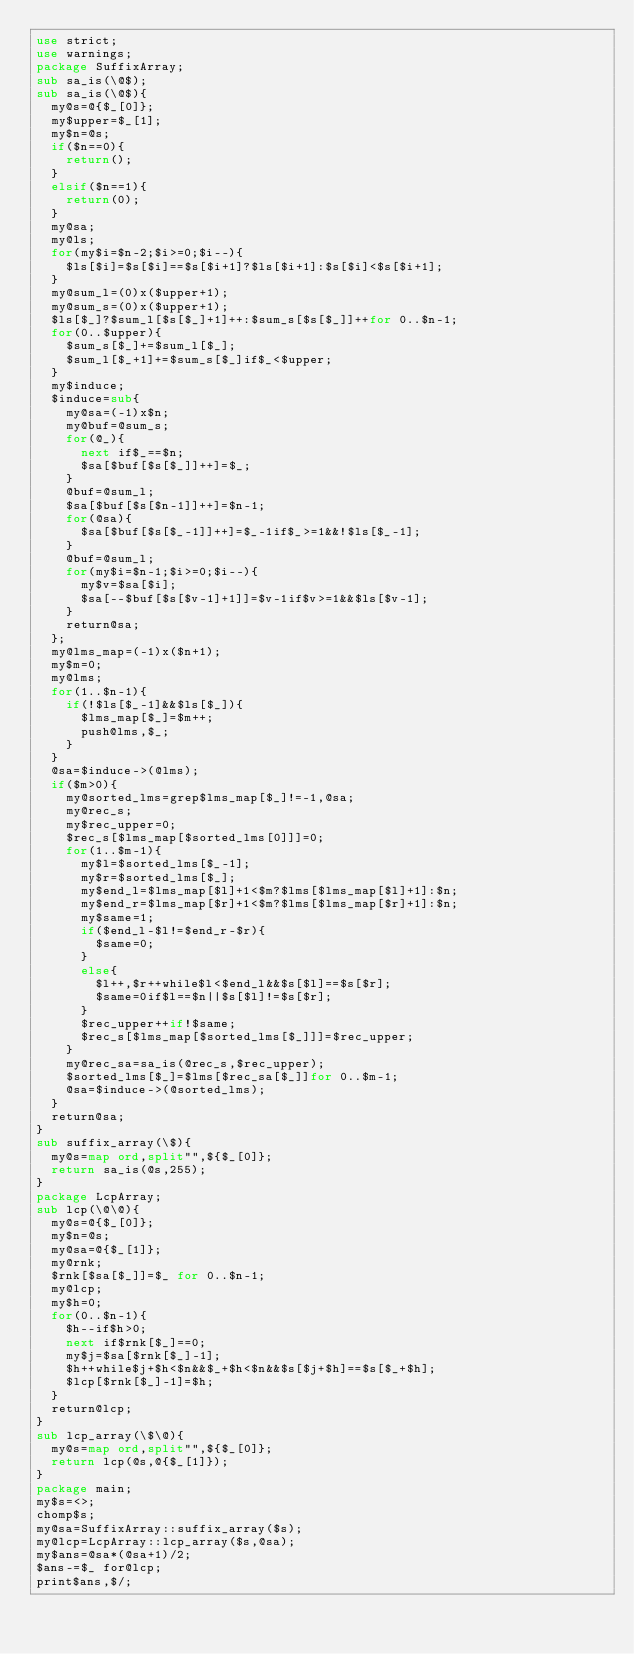<code> <loc_0><loc_0><loc_500><loc_500><_Perl_>use strict;
use warnings;
package SuffixArray;
sub sa_is(\@$);
sub sa_is(\@$){
	my@s=@{$_[0]};
	my$upper=$_[1];
	my$n=@s;
	if($n==0){
		return();
	}
	elsif($n==1){
		return(0);
	}
	my@sa;
	my@ls;
	for(my$i=$n-2;$i>=0;$i--){
		$ls[$i]=$s[$i]==$s[$i+1]?$ls[$i+1]:$s[$i]<$s[$i+1];
	}
	my@sum_l=(0)x($upper+1);
	my@sum_s=(0)x($upper+1);
	$ls[$_]?$sum_l[$s[$_]+1]++:$sum_s[$s[$_]]++for 0..$n-1;
	for(0..$upper){
		$sum_s[$_]+=$sum_l[$_];
		$sum_l[$_+1]+=$sum_s[$_]if$_<$upper;
	}
	my$induce;
	$induce=sub{
		my@sa=(-1)x$n;
		my@buf=@sum_s;
		for(@_){
			next if$_==$n;
			$sa[$buf[$s[$_]]++]=$_;
		}
		@buf=@sum_l;
		$sa[$buf[$s[$n-1]]++]=$n-1;
		for(@sa){
			$sa[$buf[$s[$_-1]]++]=$_-1if$_>=1&&!$ls[$_-1];
		}
		@buf=@sum_l;
		for(my$i=$n-1;$i>=0;$i--){
			my$v=$sa[$i];
			$sa[--$buf[$s[$v-1]+1]]=$v-1if$v>=1&&$ls[$v-1];
		}
		return@sa;
	};
	my@lms_map=(-1)x($n+1);
	my$m=0;
	my@lms;
	for(1..$n-1){
		if(!$ls[$_-1]&&$ls[$_]){
			$lms_map[$_]=$m++;
			push@lms,$_;
		}
	}
	@sa=$induce->(@lms);
	if($m>0){
		my@sorted_lms=grep$lms_map[$_]!=-1,@sa;
		my@rec_s;
		my$rec_upper=0;
		$rec_s[$lms_map[$sorted_lms[0]]]=0;
		for(1..$m-1){
			my$l=$sorted_lms[$_-1];
			my$r=$sorted_lms[$_];
			my$end_l=$lms_map[$l]+1<$m?$lms[$lms_map[$l]+1]:$n;
			my$end_r=$lms_map[$r]+1<$m?$lms[$lms_map[$r]+1]:$n;
			my$same=1;
			if($end_l-$l!=$end_r-$r){
				$same=0;
			}
			else{
				$l++,$r++while$l<$end_l&&$s[$l]==$s[$r];
				$same=0if$l==$n||$s[$l]!=$s[$r];
			}
			$rec_upper++if!$same;
			$rec_s[$lms_map[$sorted_lms[$_]]]=$rec_upper;
		}
		my@rec_sa=sa_is(@rec_s,$rec_upper);
		$sorted_lms[$_]=$lms[$rec_sa[$_]]for 0..$m-1;
		@sa=$induce->(@sorted_lms);
	}
	return@sa;
}
sub suffix_array(\$){
	my@s=map ord,split"",${$_[0]};
	return sa_is(@s,255);
}
package LcpArray;
sub lcp(\@\@){
	my@s=@{$_[0]};
	my$n=@s;
	my@sa=@{$_[1]};
	my@rnk;
	$rnk[$sa[$_]]=$_ for 0..$n-1;
	my@lcp;
	my$h=0;
	for(0..$n-1){
		$h--if$h>0;
		next if$rnk[$_]==0;
		my$j=$sa[$rnk[$_]-1];
		$h++while$j+$h<$n&&$_+$h<$n&&$s[$j+$h]==$s[$_+$h];
		$lcp[$rnk[$_]-1]=$h;
	}
	return@lcp;
}
sub lcp_array(\$\@){
	my@s=map ord,split"",${$_[0]};
	return lcp(@s,@{$_[1]});
}
package main;
my$s=<>;
chomp$s;
my@sa=SuffixArray::suffix_array($s);
my@lcp=LcpArray::lcp_array($s,@sa);
my$ans=@sa*(@sa+1)/2;
$ans-=$_ for@lcp;
print$ans,$/;
</code> 